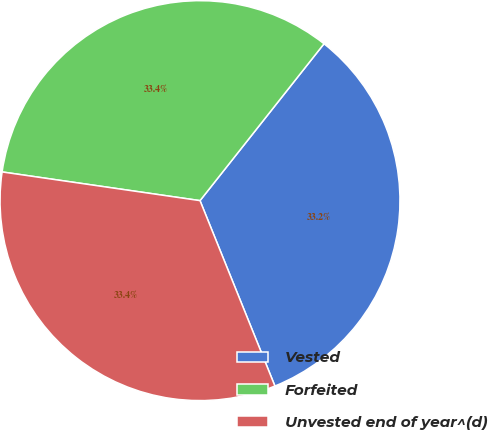Convert chart. <chart><loc_0><loc_0><loc_500><loc_500><pie_chart><fcel>Vested<fcel>Forfeited<fcel>Unvested end of year^(d)<nl><fcel>33.24%<fcel>33.35%<fcel>33.4%<nl></chart> 